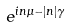<formula> <loc_0><loc_0><loc_500><loc_500>e ^ { i n \mu - | n | \gamma }</formula> 